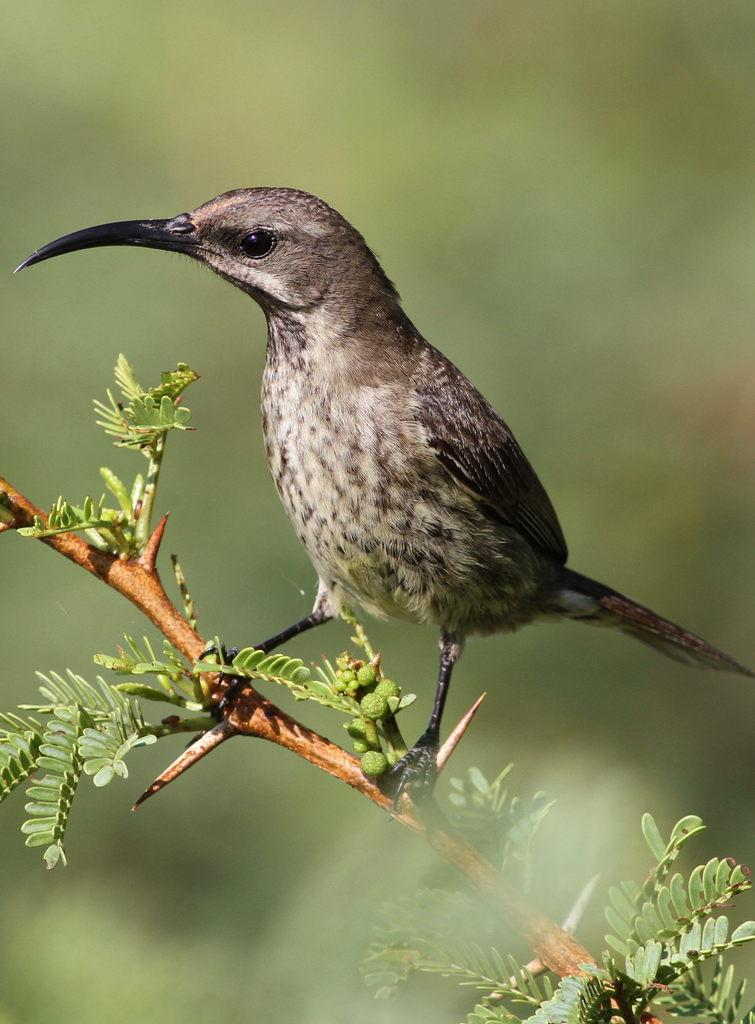What type of animal can be seen in the image? There is a bird with a long beak in the image. Where is the bird located in the image? The bird is standing on the stem of a plant. Can you describe the background of the image? The background of the image is blurred. What type of gate can be seen in the image? There is no gate present in the image; it features a bird standing on the stem of a plant. Is there any fire or flame visible in the image? There is no fire or flame present in the image. 